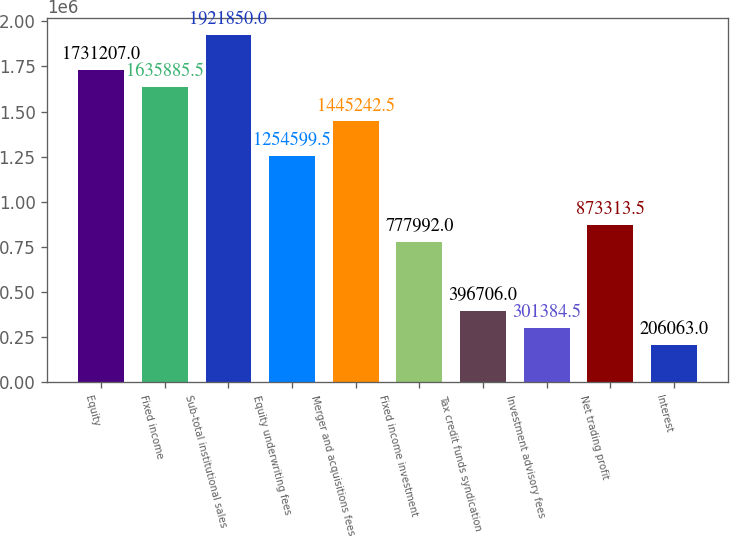<chart> <loc_0><loc_0><loc_500><loc_500><bar_chart><fcel>Equity<fcel>Fixed income<fcel>Sub-total institutional sales<fcel>Equity underwriting fees<fcel>Merger and acquisitions fees<fcel>Fixed income investment<fcel>Tax credit funds syndication<fcel>Investment advisory fees<fcel>Net trading profit<fcel>Interest<nl><fcel>1.73121e+06<fcel>1.63589e+06<fcel>1.92185e+06<fcel>1.2546e+06<fcel>1.44524e+06<fcel>777992<fcel>396706<fcel>301384<fcel>873314<fcel>206063<nl></chart> 